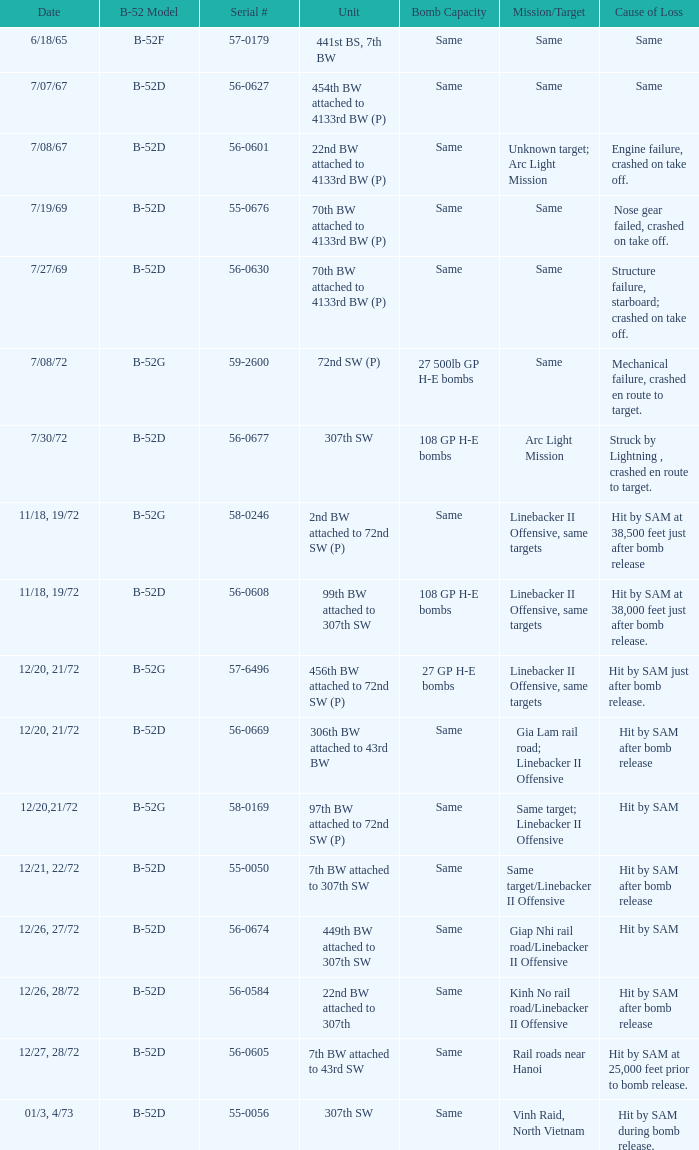When struck by a sam at 38,500 feet immediately following bomb deployment, what was the objective/destination of the loss? Linebacker II Offensive, same targets. 